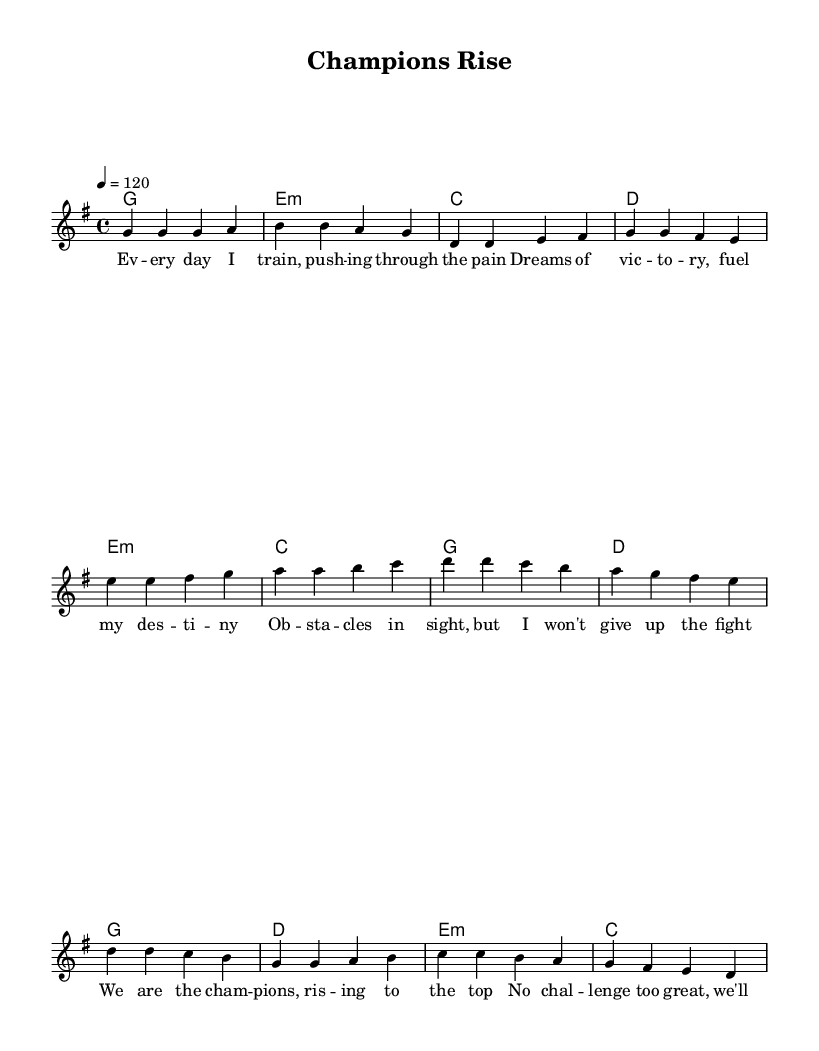What is the key signature of this music? The key signature is G major, which has one sharp (F#). It is indicated at the beginning of the staff where the sharps are listed.
Answer: G major What is the time signature of this music? The time signature is 4/4, shown at the beginning of the score right after the key signature. This means there are four beats in a measure.
Answer: 4/4 What is the tempo marking of this music? The tempo marking is 120 beats per minute, written as "4 = 120" under the tempo instruction. This indicates how fast the music should be played.
Answer: 120 How many measures are in the chorus? The chorus section contains four measures, as the music is divided into segments by vertical lines, called bar lines, which separate the measures.
Answer: 4 What is the primary theme of the lyrics? The primary theme of the lyrics focuses on overcoming challenges and striving for victory, as indicated by phrases in the lyrics that suggest persistence and ambition.
Answer: Overcoming challenges What type of musical structure does this song follow? The song follows a verse-prechorus-chorus structure, which is typical in pop music, allowing for dynamic variation and building up to the main message of the song.
Answer: Verse-prechorus-chorus 